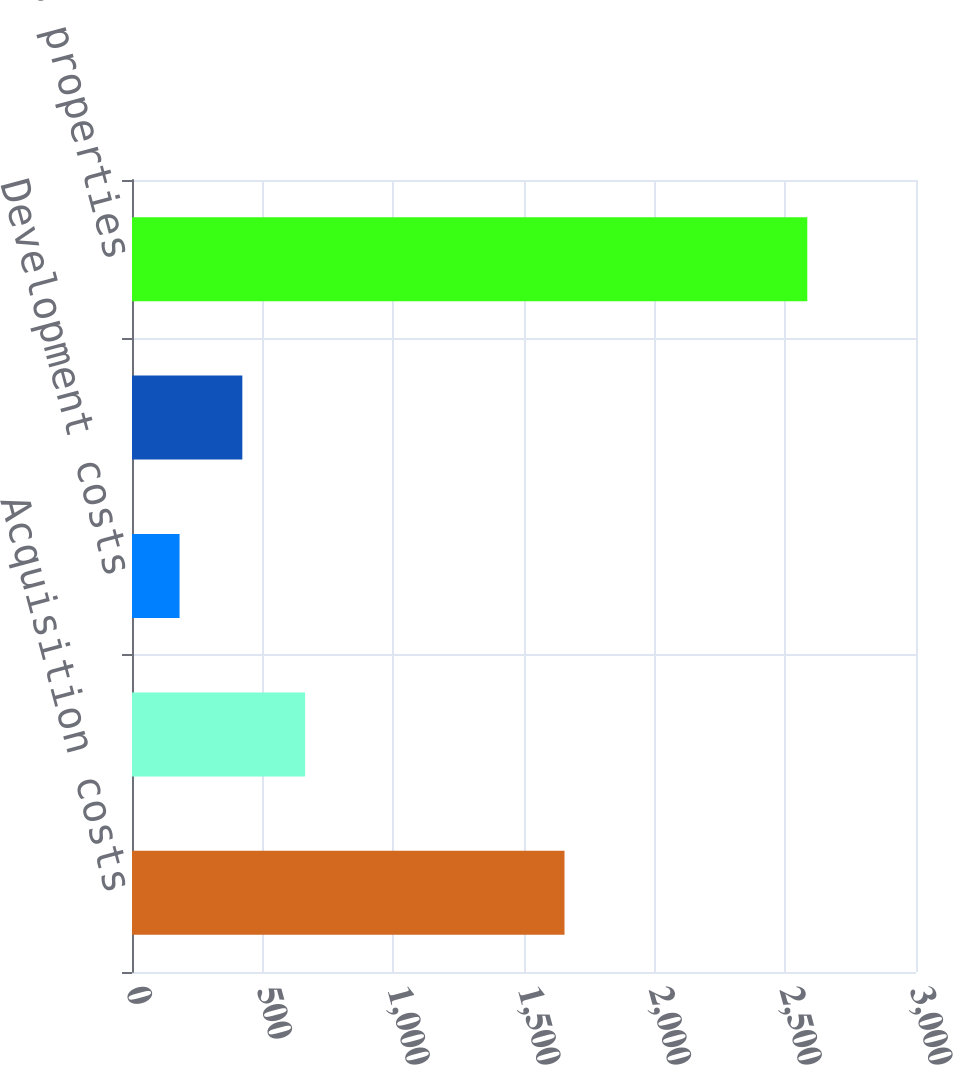Convert chart. <chart><loc_0><loc_0><loc_500><loc_500><bar_chart><fcel>Acquisition costs<fcel>Exploration costs<fcel>Development costs<fcel>Capitalized interest<fcel>Total oil and gas properties<nl><fcel>1655<fcel>662.4<fcel>182<fcel>422.2<fcel>2584<nl></chart> 